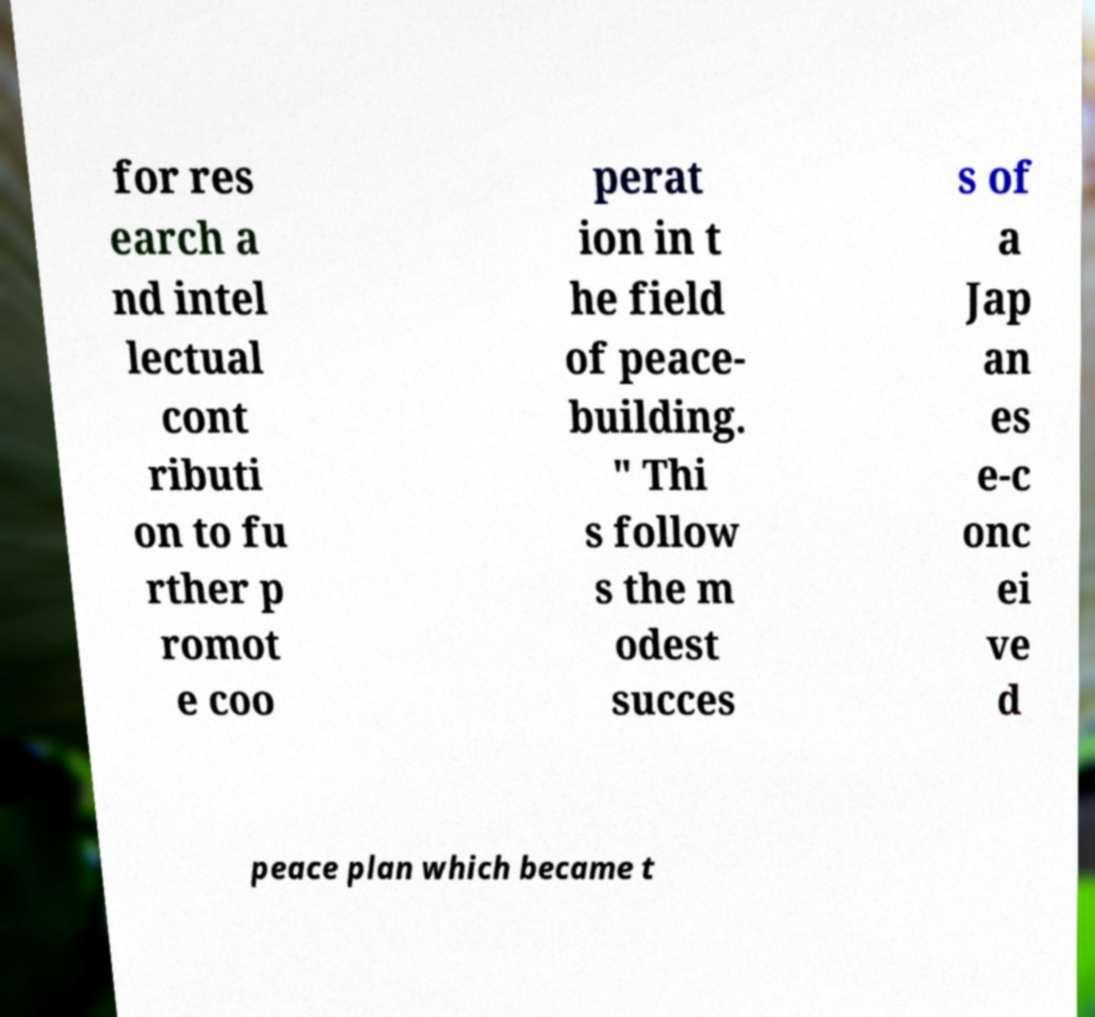Please identify and transcribe the text found in this image. for res earch a nd intel lectual cont ributi on to fu rther p romot e coo perat ion in t he field of peace- building. " Thi s follow s the m odest succes s of a Jap an es e-c onc ei ve d peace plan which became t 